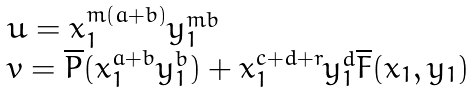Convert formula to latex. <formula><loc_0><loc_0><loc_500><loc_500>\begin{array} { l } u = x _ { 1 } ^ { m ( a + b ) } y _ { 1 } ^ { m b } \\ v = \overline { P } ( x _ { 1 } ^ { a + b } y _ { 1 } ^ { b } ) + x _ { 1 } ^ { c + d + r } y _ { 1 } ^ { d } \overline { F } ( x _ { 1 } , y _ { 1 } ) \end{array}</formula> 